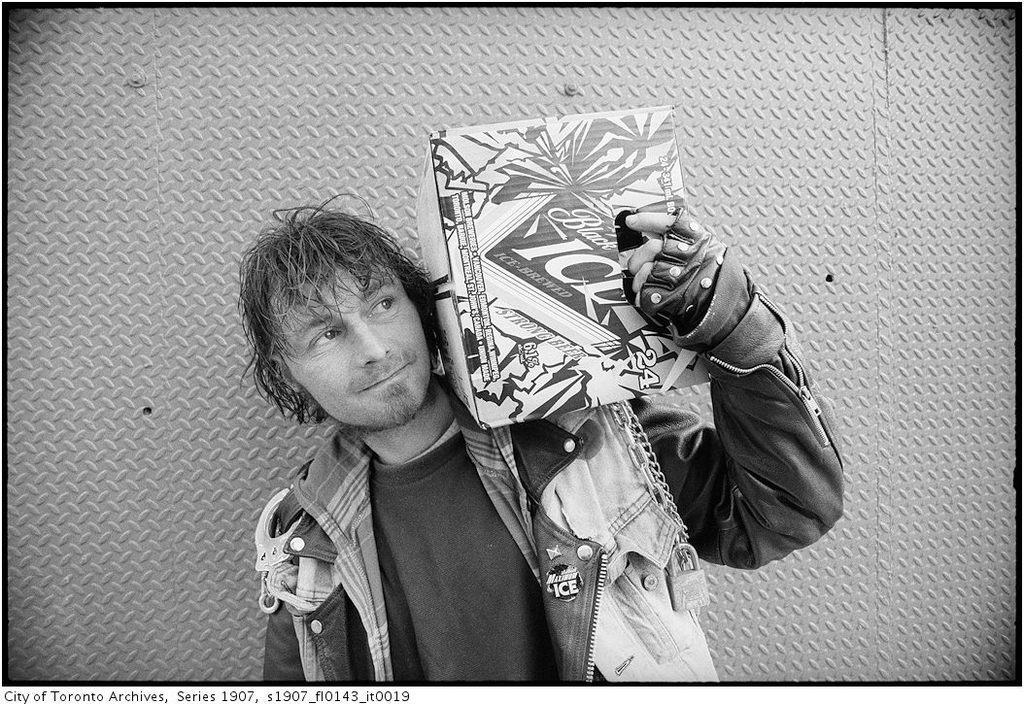How would you summarize this image in a sentence or two? In this picture there is a man who is wearing jacket, t-shirt and gloves. He is holding a cotton box, beside him we can see the wall. In the bottom left there is a watermark. 